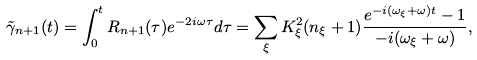<formula> <loc_0><loc_0><loc_500><loc_500>\tilde { \gamma } _ { n + 1 } ( t ) = \int _ { 0 } ^ { t } R _ { n + 1 } ( \tau ) e ^ { - 2 i \omega \tau } d \tau = \sum _ { \xi } K _ { \xi } ^ { 2 } ( n _ { \xi } + 1 ) \frac { e ^ { - i ( \omega _ { \xi } + \omega ) t } - 1 } { - i ( \omega _ { \xi } + \omega ) } ,</formula> 